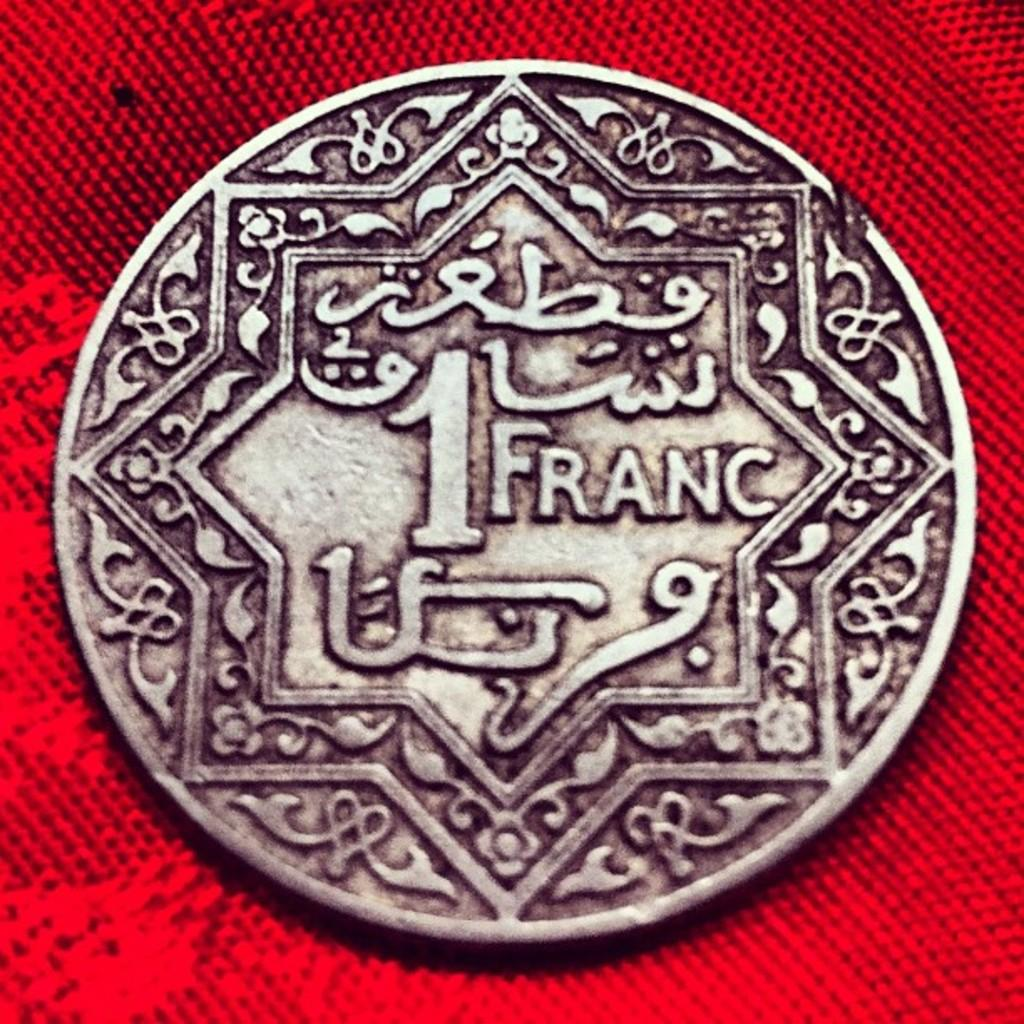<image>
Share a concise interpretation of the image provided. a close up of a coin with arabic writing for 1 Franc 